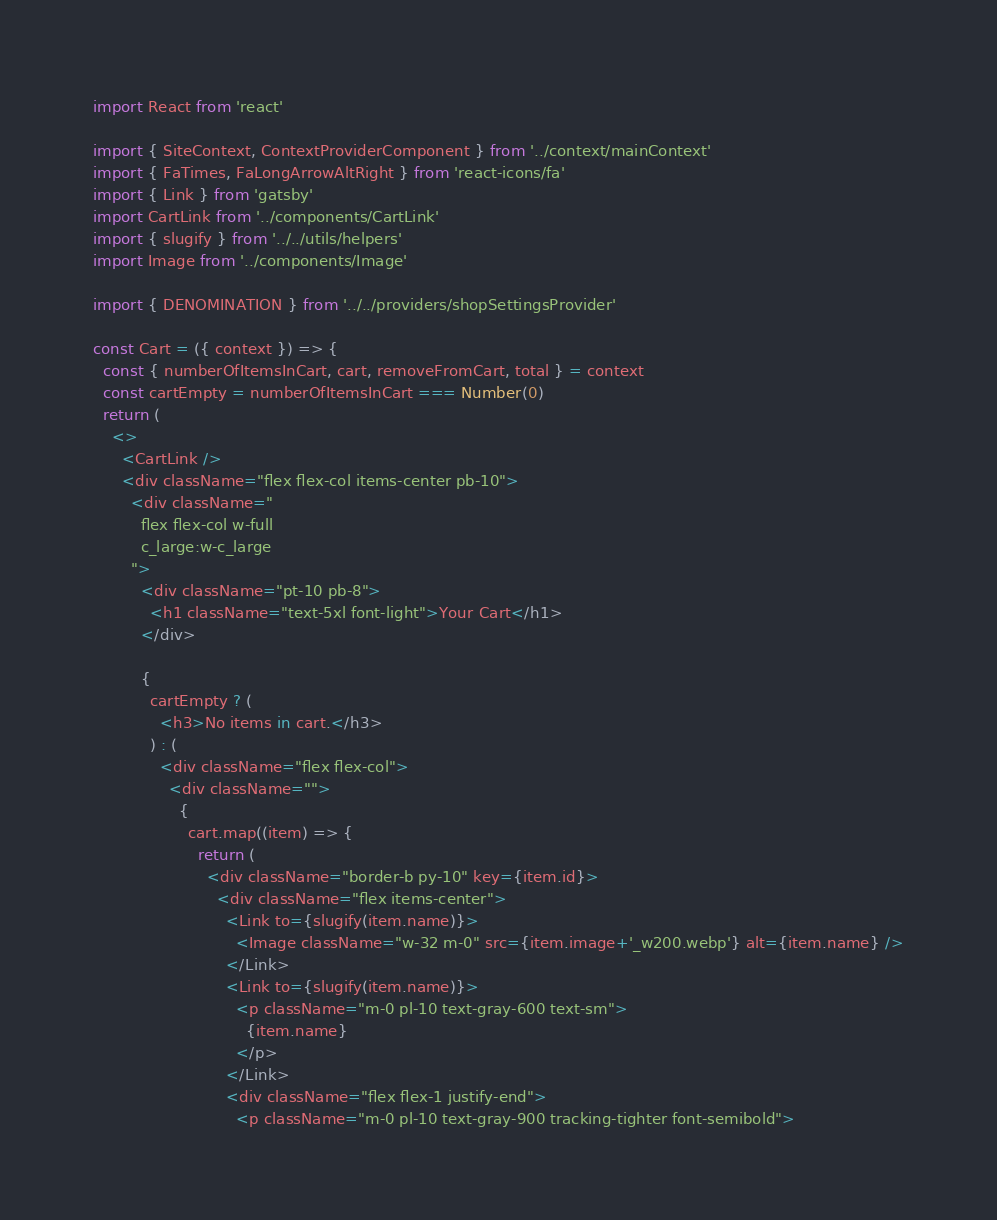<code> <loc_0><loc_0><loc_500><loc_500><_JavaScript_>import React from 'react'

import { SiteContext, ContextProviderComponent } from '../context/mainContext'
import { FaTimes, FaLongArrowAltRight } from 'react-icons/fa'
import { Link } from 'gatsby'
import CartLink from '../components/CartLink'
import { slugify } from '../../utils/helpers'
import Image from '../components/Image'

import { DENOMINATION } from '../../providers/shopSettingsProvider'

const Cart = ({ context }) => {
  const { numberOfItemsInCart, cart, removeFromCart, total } = context
  const cartEmpty = numberOfItemsInCart === Number(0)
  return (
    <>
      <CartLink />
      <div className="flex flex-col items-center pb-10">
        <div className="
          flex flex-col w-full
          c_large:w-c_large
        ">
          <div className="pt-10 pb-8">
            <h1 className="text-5xl font-light">Your Cart</h1>
          </div>

          {
            cartEmpty ? (
              <h3>No items in cart.</h3>
            ) : (
              <div className="flex flex-col">
                <div className="">
                  {
                    cart.map((item) => {
                      return (
                        <div className="border-b py-10" key={item.id}>
                          <div className="flex items-center">
                            <Link to={slugify(item.name)}>
                              <Image className="w-32 m-0" src={item.image+'_w200.webp'} alt={item.name} />
                            </Link>
                            <Link to={slugify(item.name)}>
                              <p className="m-0 pl-10 text-gray-600 text-sm">
                                {item.name}
                              </p>
                            </Link>
                            <div className="flex flex-1 justify-end">
                              <p className="m-0 pl-10 text-gray-900 tracking-tighter font-semibold"></code> 